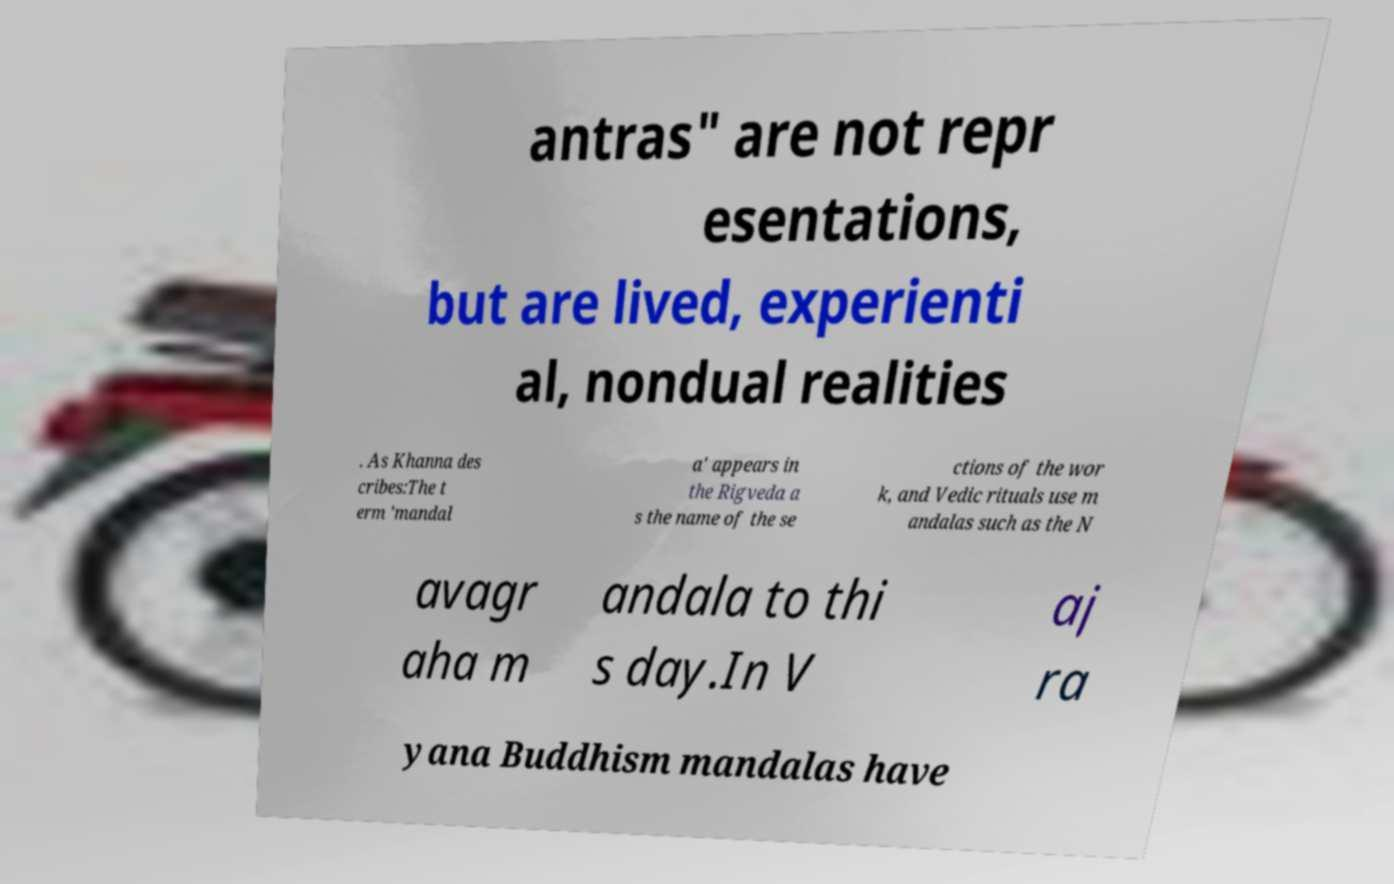There's text embedded in this image that I need extracted. Can you transcribe it verbatim? antras" are not repr esentations, but are lived, experienti al, nondual realities . As Khanna des cribes:The t erm 'mandal a' appears in the Rigveda a s the name of the se ctions of the wor k, and Vedic rituals use m andalas such as the N avagr aha m andala to thi s day.In V aj ra yana Buddhism mandalas have 